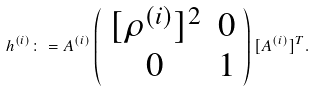<formula> <loc_0><loc_0><loc_500><loc_500>h ^ { ( i ) } \colon = A ^ { ( i ) } \left ( \begin{array} { c c } [ \rho ^ { ( i ) } ] ^ { 2 } & 0 \\ 0 & 1 \end{array} \right ) [ A ^ { ( i ) } ] ^ { T } .</formula> 